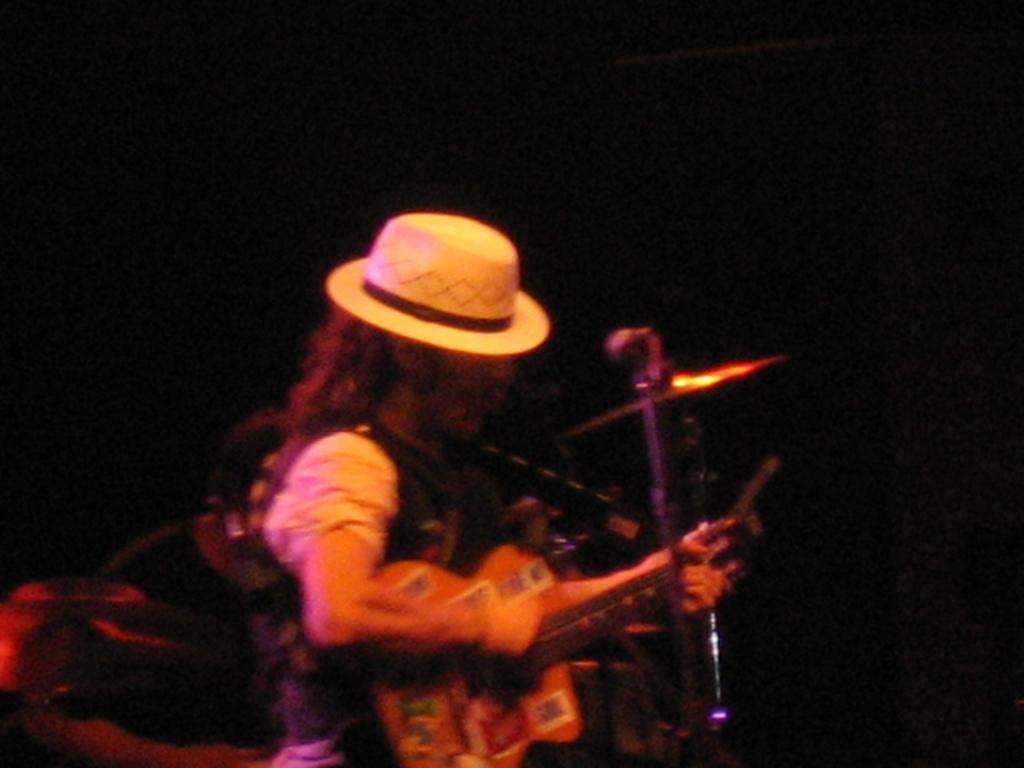In one or two sentences, can you explain what this image depicts? In this image there is a man playing guitar in front of a mic, in the background it is dark. 